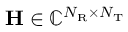<formula> <loc_0><loc_0><loc_500><loc_500>H \in \mathbb { C } ^ { N _ { R } \times N _ { T } }</formula> 